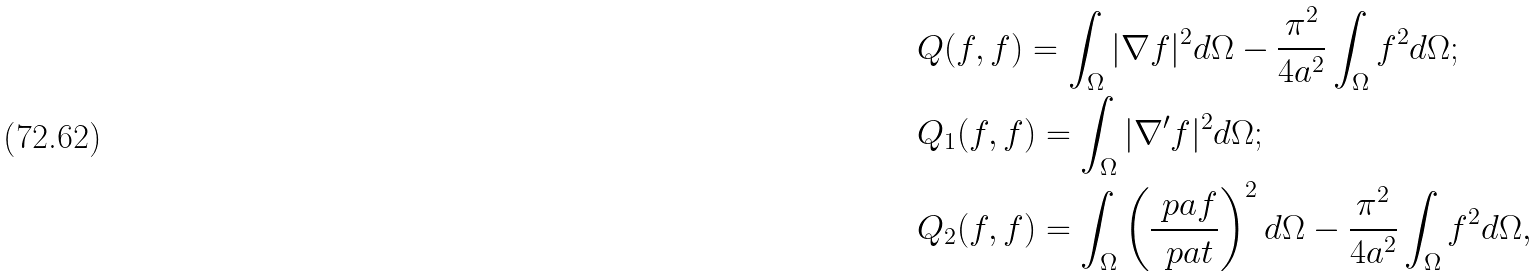<formula> <loc_0><loc_0><loc_500><loc_500>& Q ( f , f ) = \int _ { \Omega } | \nabla f | ^ { 2 } d \Omega - \frac { \pi ^ { 2 } } { 4 a ^ { 2 } } \int _ { \Omega } f ^ { 2 } d \Omega ; \\ & Q _ { 1 } ( f , f ) = \int _ { \Omega } | \nabla ^ { \prime } f | ^ { 2 } d \Omega ; \\ & Q _ { 2 } ( f , f ) = \int _ { \Omega } \left ( \frac { \ p a f } { \ p a t } \right ) ^ { 2 } d \Omega - \frac { \pi ^ { 2 } } { 4 a ^ { 2 } } \int _ { \Omega } f ^ { 2 } d \Omega ,</formula> 